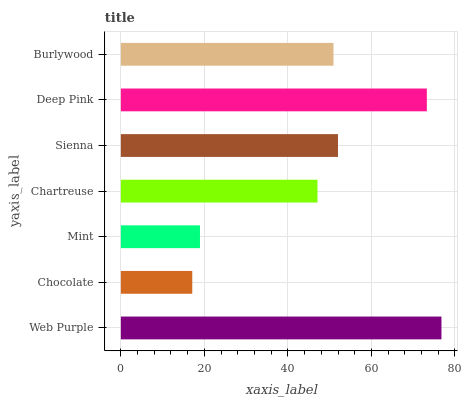Is Chocolate the minimum?
Answer yes or no. Yes. Is Web Purple the maximum?
Answer yes or no. Yes. Is Mint the minimum?
Answer yes or no. No. Is Mint the maximum?
Answer yes or no. No. Is Mint greater than Chocolate?
Answer yes or no. Yes. Is Chocolate less than Mint?
Answer yes or no. Yes. Is Chocolate greater than Mint?
Answer yes or no. No. Is Mint less than Chocolate?
Answer yes or no. No. Is Burlywood the high median?
Answer yes or no. Yes. Is Burlywood the low median?
Answer yes or no. Yes. Is Chocolate the high median?
Answer yes or no. No. Is Sienna the low median?
Answer yes or no. No. 